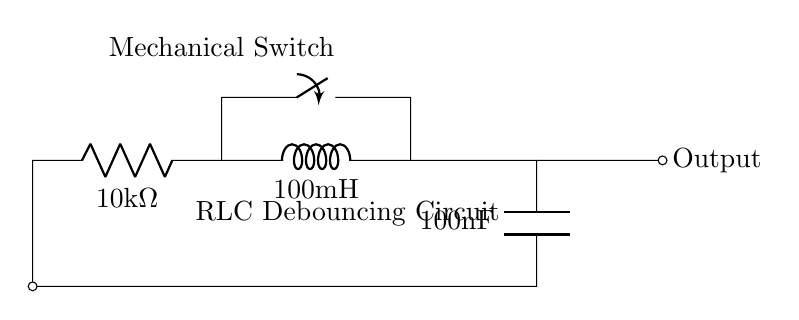What is the resistance value in this circuit? The resistance component labeled as R is denoted as R1 with a value of 10 kΩ.
Answer: 10 kΩ What is the inductance in this circuit? The inductor component labeled as L is denoted as L1 with a value of 100 mH.
Answer: 100 mH What is the capacitance value in this circuit? The capacitor component labeled as C is denoted as C1 with a value of 100 nF.
Answer: 100 nF How does this circuit help in debouncing a mechanical switch? The RLC circuit filters out the noise generated from the mechanical switch bounce; the combination of resistance, inductance, and capacitance helps to smooth out the signal, ensuring a clean transition.
Answer: Filters noise What happens to the output when the mechanical switch is pressed? When the switch is closed, the circuit activates, allowing current to flow through the RLC network, which charges the capacitor and produces a smooth output voltage.
Answer: Activates circuit What is the role of the resistor in the RLC circuit? The resistor in this RLC circuit dissipates energy and controls the charge and discharge rates of the capacitor, affecting the timing characteristics of the debouncing process.
Answer: Controls timing What kind of circuit is this being described? This circuit is a type of passive filter circuit, specifically a RLC debouncing circuit used for mechanical switch debouncing.
Answer: RLC debouncing circuit 